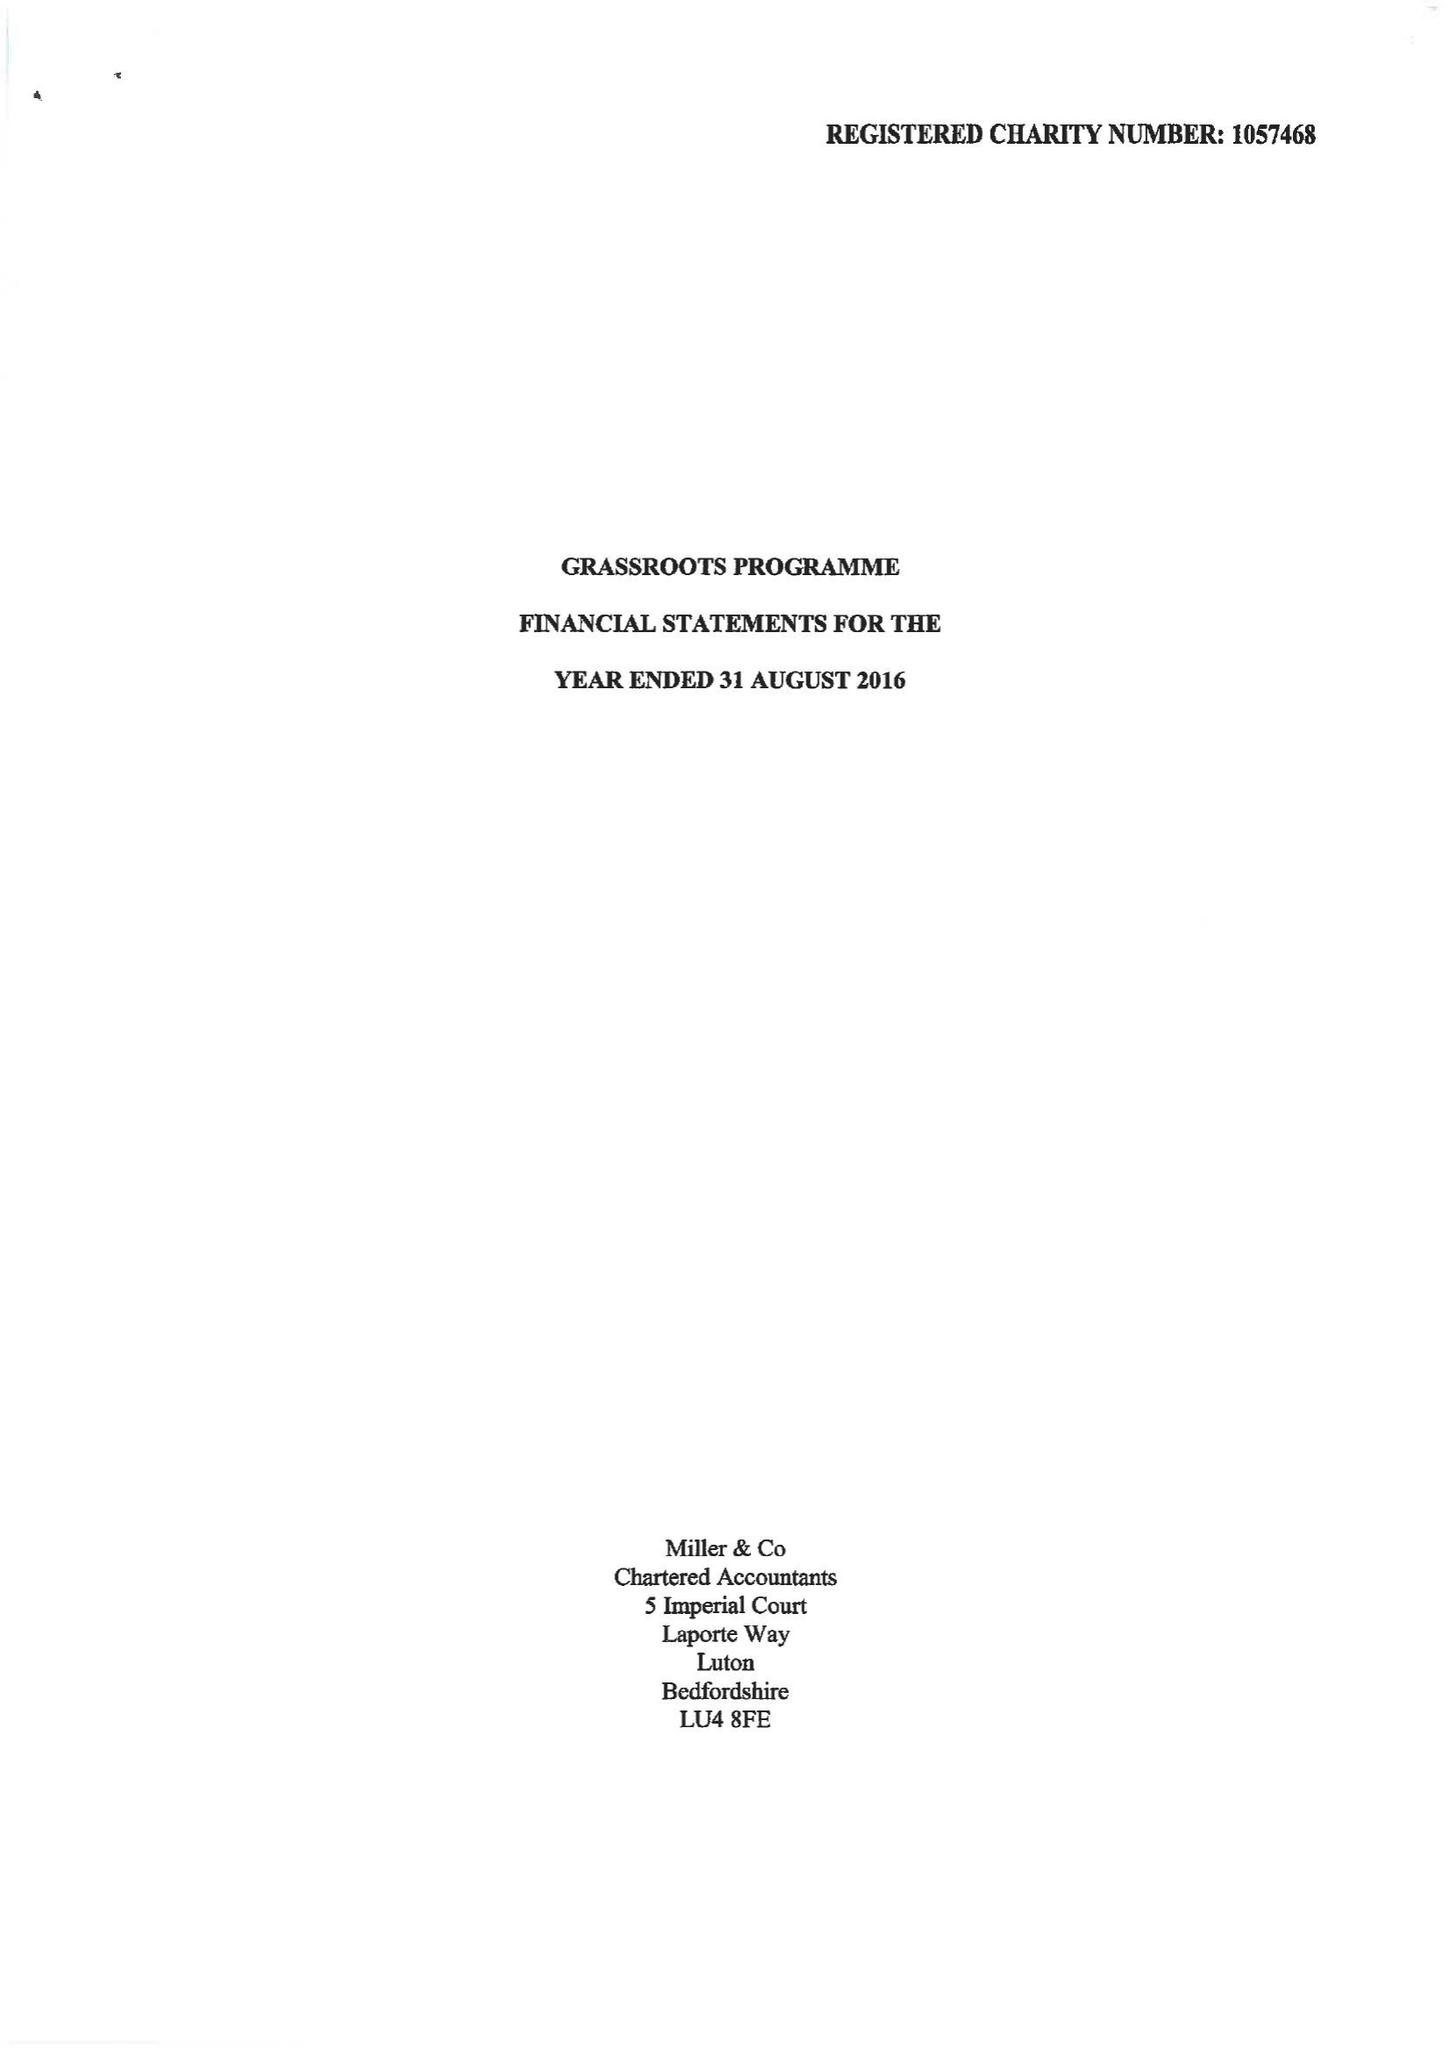What is the value for the report_date?
Answer the question using a single word or phrase. 2016-08-31 